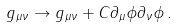Convert formula to latex. <formula><loc_0><loc_0><loc_500><loc_500>g _ { \mu \nu } \to g _ { \mu \nu } + C \partial _ { \mu } \phi \partial _ { \nu } \phi \, .</formula> 